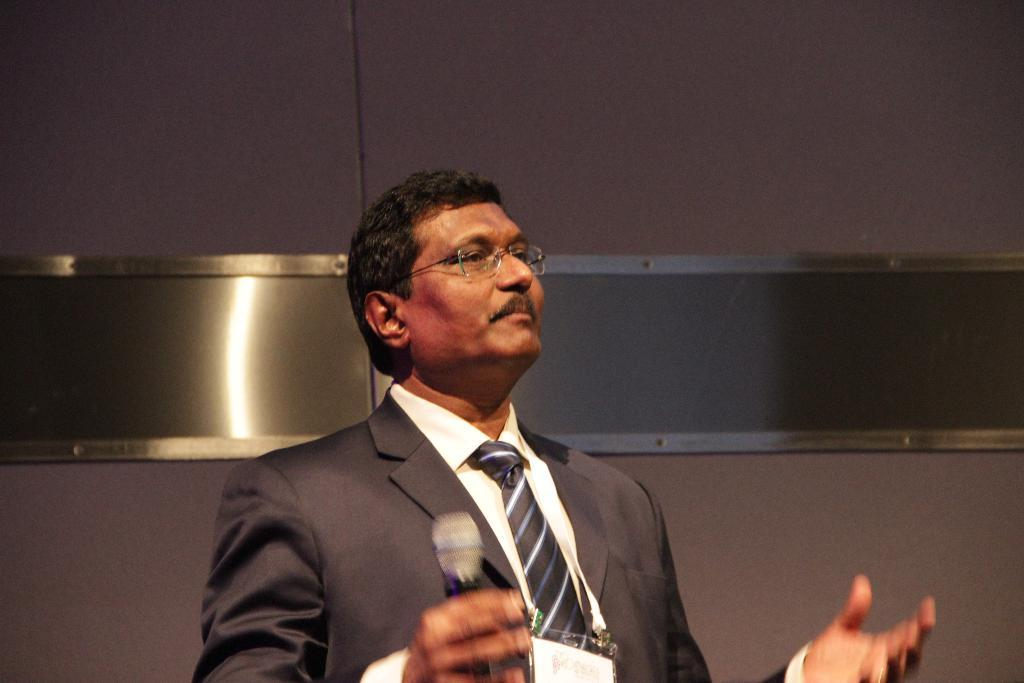What is the main subject of the image? There is a man in the image. What is the man doing in the image? The man is standing and holding a microphone with his right hand. What might the man be focusing on in the image? The man is looking at something, which suggests he is focused on it. What type of quilt is being used to balance the microphone in the image? There is no quilt present in the image, and the microphone is being held by the man, not balanced on a quilt. 